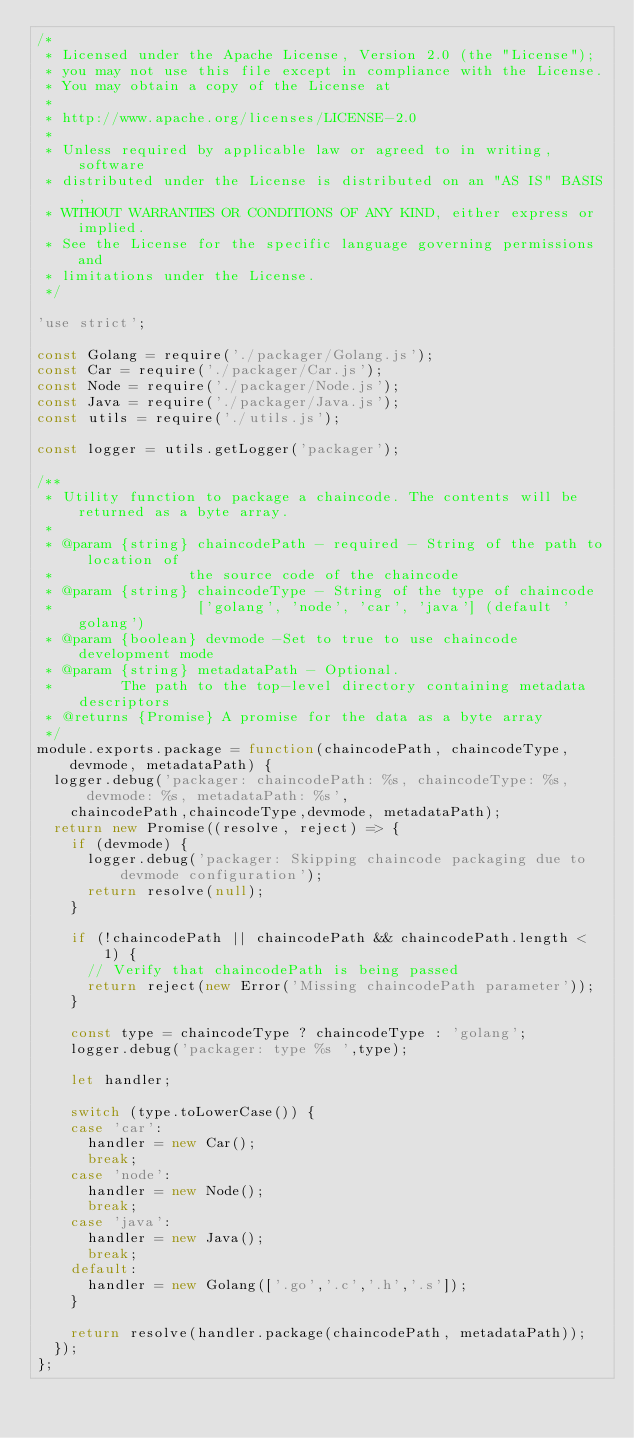<code> <loc_0><loc_0><loc_500><loc_500><_JavaScript_>/*
 * Licensed under the Apache License, Version 2.0 (the "License");
 * you may not use this file except in compliance with the License.
 * You may obtain a copy of the License at
 *
 * http://www.apache.org/licenses/LICENSE-2.0
 *
 * Unless required by applicable law or agreed to in writing, software
 * distributed under the License is distributed on an "AS IS" BASIS,
 * WITHOUT WARRANTIES OR CONDITIONS OF ANY KIND, either express or implied.
 * See the License for the specific language governing permissions and
 * limitations under the License.
 */

'use strict';

const Golang = require('./packager/Golang.js');
const Car = require('./packager/Car.js');
const Node = require('./packager/Node.js');
const Java = require('./packager/Java.js');
const utils = require('./utils.js');

const logger = utils.getLogger('packager');

/**
 * Utility function to package a chaincode. The contents will be returned as a byte array.
 *
 * @param {string} chaincodePath - required - String of the path to location of
 *                the source code of the chaincode
 * @param {string} chaincodeType - String of the type of chaincode
 *                 ['golang', 'node', 'car', 'java'] (default 'golang')
 * @param {boolean} devmode -Set to true to use chaincode development mode
 * @param {string} metadataPath - Optional.
 *        The path to the top-level directory containing metadata descriptors
 * @returns {Promise} A promise for the data as a byte array
 */
module.exports.package = function(chaincodePath, chaincodeType, devmode, metadataPath) {
	logger.debug('packager: chaincodePath: %s, chaincodeType: %s, devmode: %s, metadataPath: %s',
		chaincodePath,chaincodeType,devmode, metadataPath);
	return new Promise((resolve, reject) => {
		if (devmode) {
			logger.debug('packager: Skipping chaincode packaging due to devmode configuration');
			return resolve(null);
		}

		if (!chaincodePath || chaincodePath && chaincodePath.length < 1) {
			// Verify that chaincodePath is being passed
			return reject(new Error('Missing chaincodePath parameter'));
		}

		const type = chaincodeType ? chaincodeType : 'golang';
		logger.debug('packager: type %s ',type);

		let handler;

		switch (type.toLowerCase()) {
		case 'car':
			handler = new Car();
			break;
		case 'node':
			handler = new Node();
			break;
		case 'java':
			handler = new Java();
			break;
		default:
			handler = new Golang(['.go','.c','.h','.s']);
		}

		return resolve(handler.package(chaincodePath, metadataPath));
	});
};
</code> 